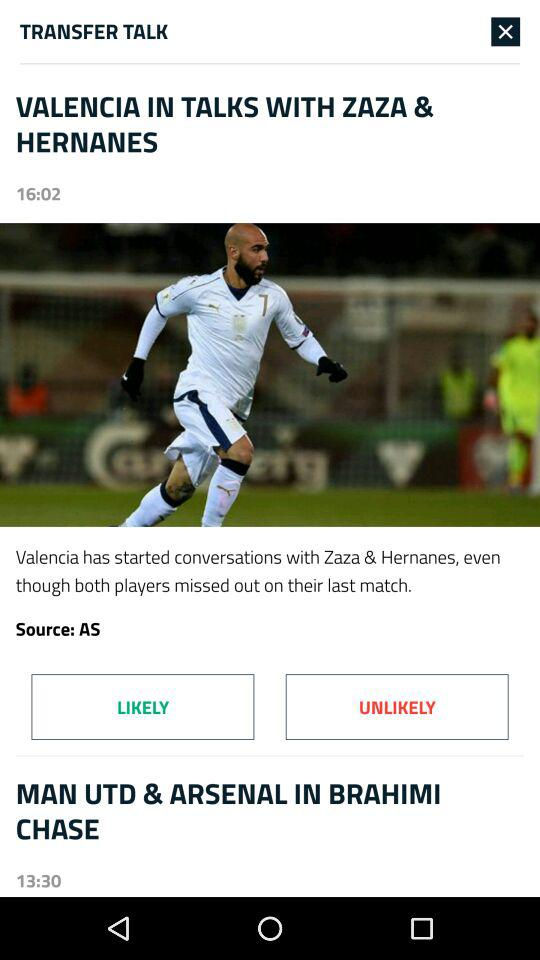Who is in talks with Zaza and Hernanes? Zaza and Hernanes are in talks with "VALENCIA". 